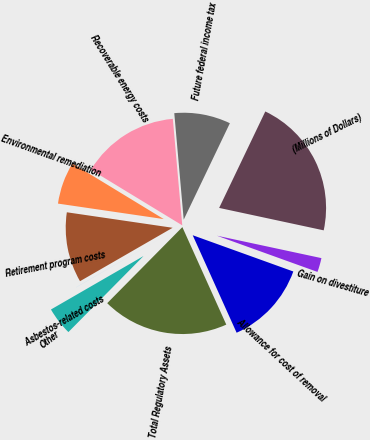<chart> <loc_0><loc_0><loc_500><loc_500><pie_chart><fcel>(Millions of Dollars)<fcel>Future federal income tax<fcel>Recoverable energy costs<fcel>Environmental remediation<fcel>Retirement program costs<fcel>Asbestos-related costs<fcel>Other<fcel>Total Regulatory Assets<fcel>Allowance for cost of removal<fcel>Gain on divestiture<nl><fcel>21.26%<fcel>8.51%<fcel>14.89%<fcel>6.39%<fcel>10.64%<fcel>0.01%<fcel>4.26%<fcel>19.14%<fcel>12.76%<fcel>2.14%<nl></chart> 